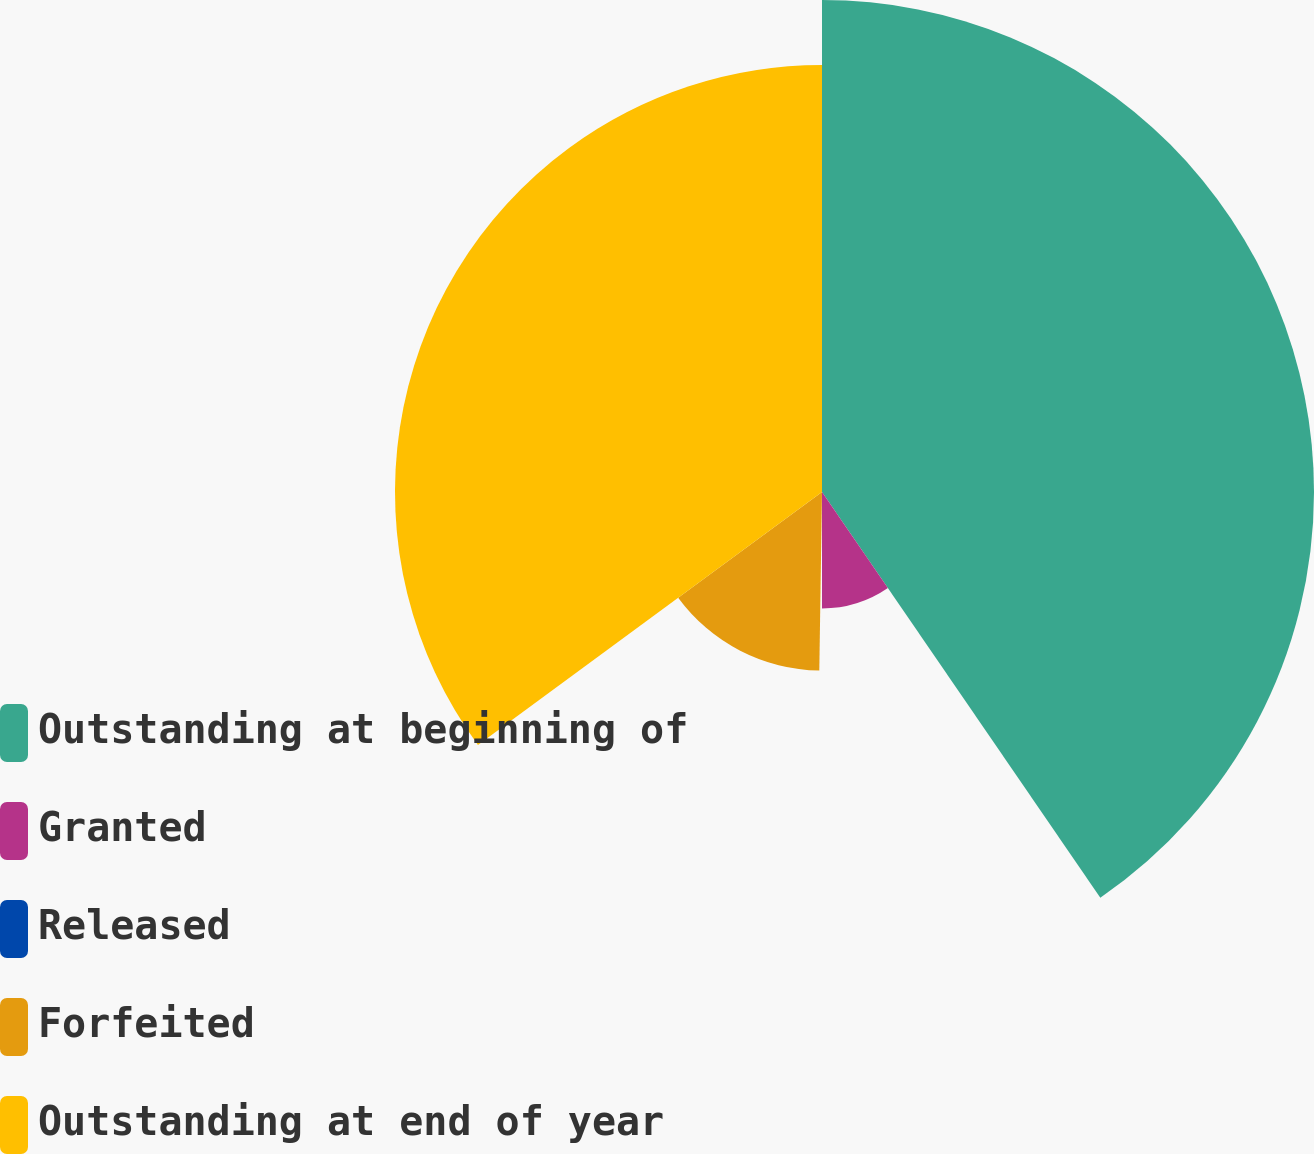Convert chart. <chart><loc_0><loc_0><loc_500><loc_500><pie_chart><fcel>Outstanding at beginning of<fcel>Granted<fcel>Released<fcel>Forfeited<fcel>Outstanding at end of year<nl><fcel>40.43%<fcel>9.57%<fcel>0.24%<fcel>14.67%<fcel>35.09%<nl></chart> 